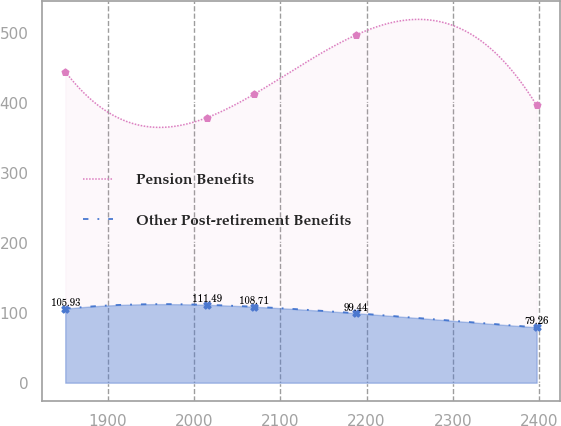Convert chart. <chart><loc_0><loc_0><loc_500><loc_500><line_chart><ecel><fcel>Pension Benefits<fcel>Other Post-retirement Benefits<nl><fcel>1850.88<fcel>445.26<fcel>105.93<nl><fcel>2015.05<fcel>379.44<fcel>111.49<nl><fcel>2069.67<fcel>413.04<fcel>108.71<nl><fcel>2187.9<fcel>497.84<fcel>99.44<nl><fcel>2397.12<fcel>397.02<fcel>79.26<nl></chart> 